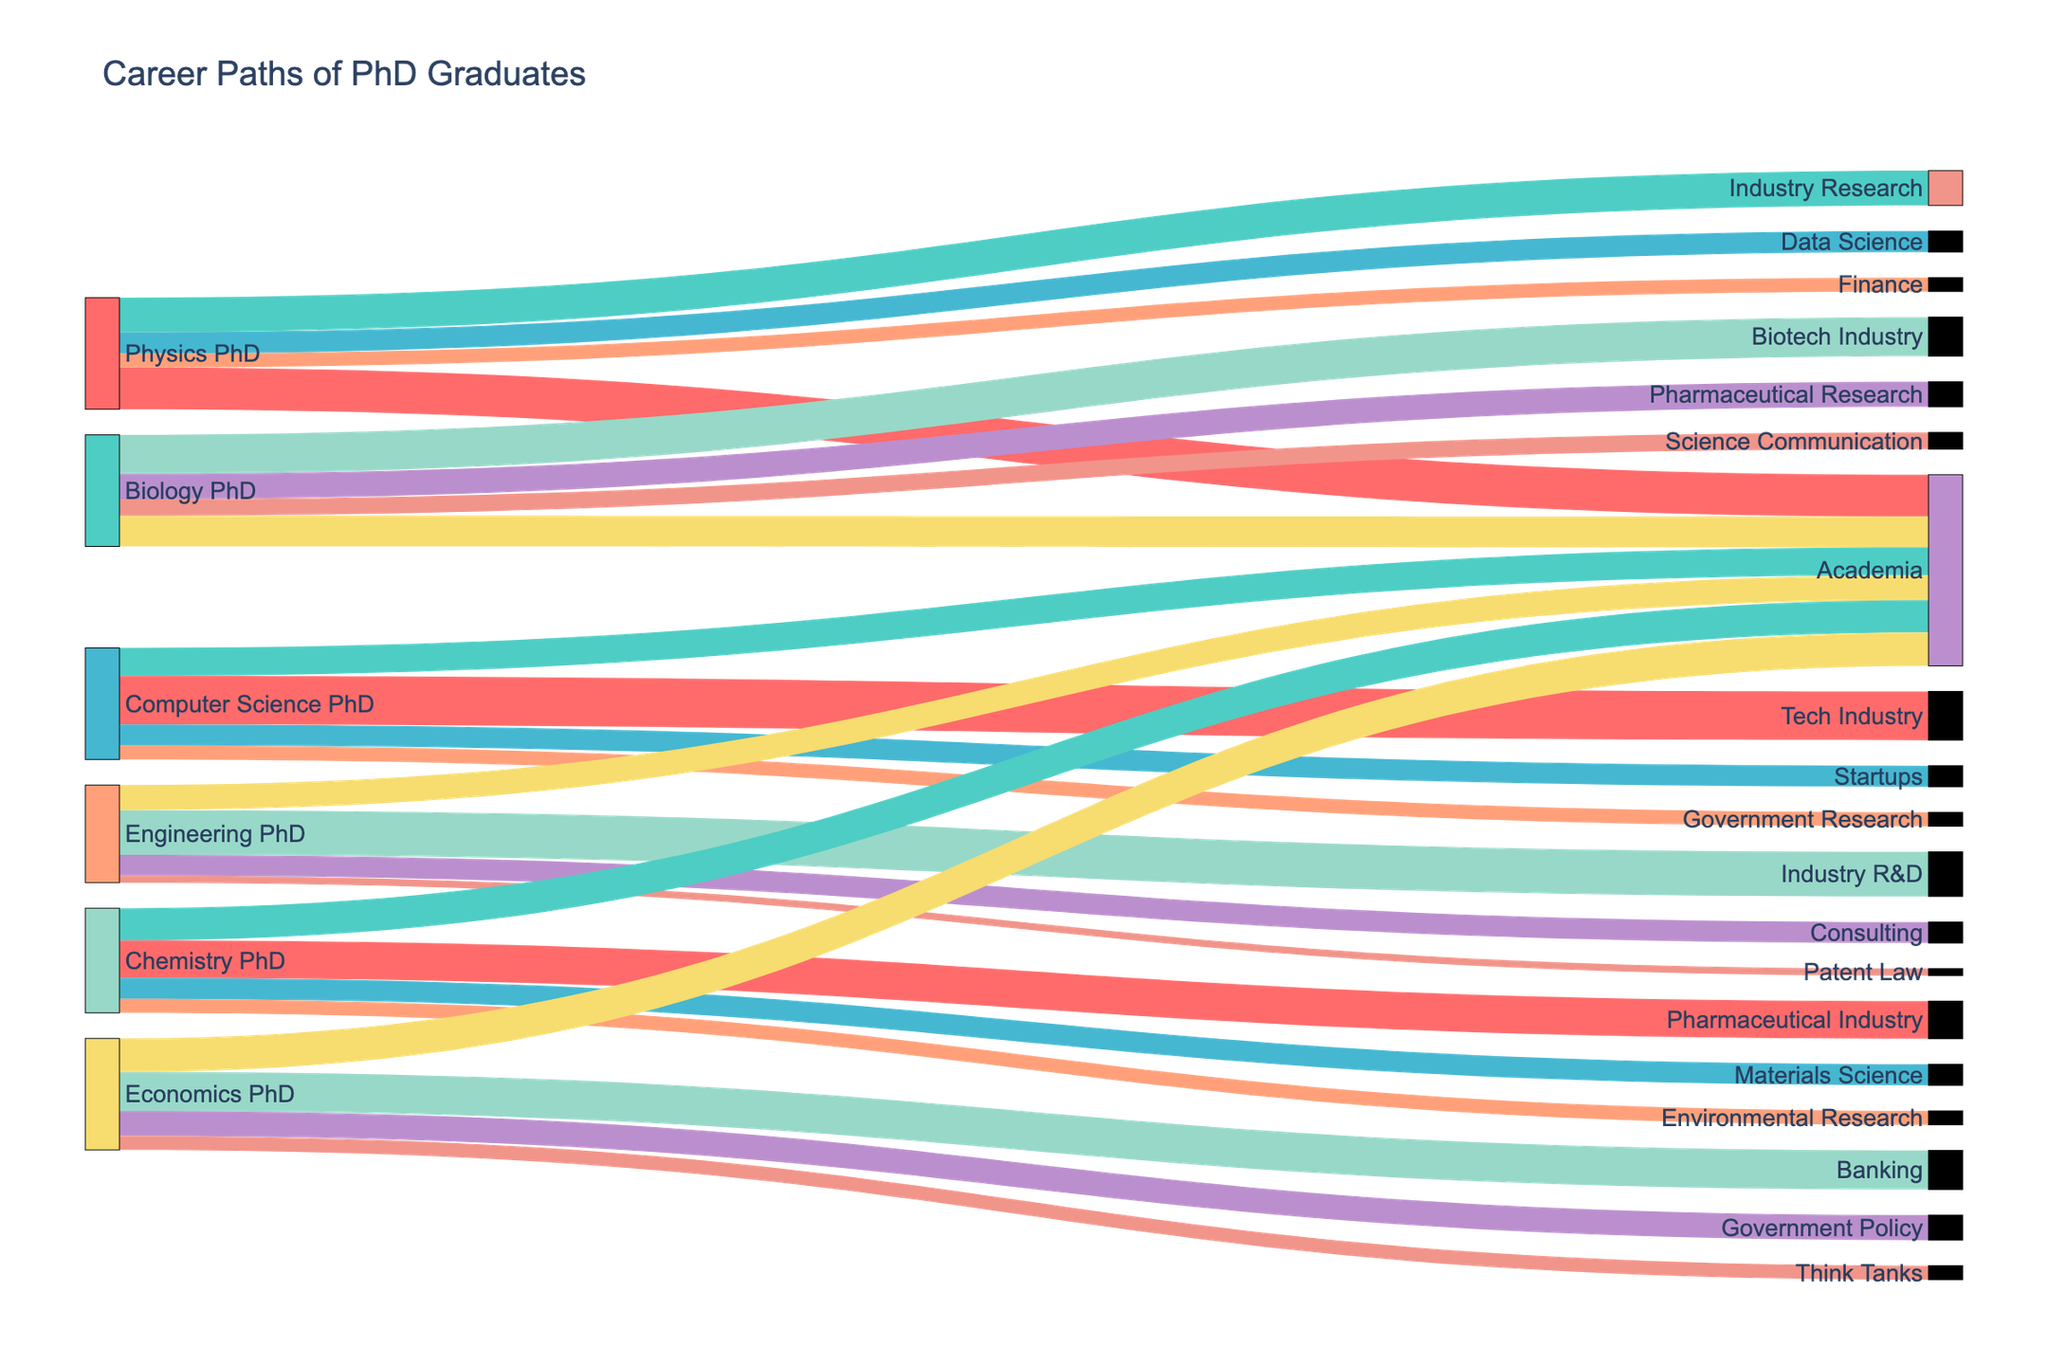What's the title of the figure? The title of the figure is typically located at the top of the visualization and provides a summary of what the figure is about. In this case, the title text is "Career Paths of PhD Graduates".
Answer: Career Paths of PhD Graduates How many different career paths are shown for Physics PhDs? Count the number of unique target labels connected to "Physics PhD" in the figure. The target labels connected here are Academia, Industry Research, Data Science, and Finance.
Answer: 4 Which career path has the highest number of Computer Science PhDs? Identify the highest value of the links connected to "Computer Science PhD". The highest value link goes to the Tech Industry with a value of 350.
Answer: Tech Industry What is the combined number of Biology PhDs in the Biotech Industry and Pharmaceutical Research? Sum the values of the links from "Biology PhD" to "Biotech Industry" and "Pharmaceutical Research". These values are 280 and 180 respectively, so 280 + 180 = 460.
Answer: 460 Which field has the least number of PhD graduates going into patent law? Identify the lowest value among the links. "Engineering PhD" has the lowest value of 50 PhDs moving into Patent Law.
Answer: Engineering PhD Compare the number of Physics PhDs in Academia to Chemistry PhDs in the same field. Which has more? Look at the values of the links connected to "Academia" from both "Physics PhD" and "Chemistry PhD". Physics PhDs in Academia have a value of 300 while Chemistry PhDs in Academia have 230. 300 is more than 230.
Answer: Physics PhDs What is the difference in the number of Engineering PhDs between Consulting and Academia? Subtract the value of "Engineering PhD" in Academia from the value in Consulting. These values are 150 (Consulting) and 180 (Academia), so 150 - 180 = -30. The absolute difference is 30.
Answer: 30 How many career paths are available for Economics PhDs as shown in the figure? Count the unique target labels connected to "Economics PhD". These are Banking, Academia, Government Policy, and Think Tanks, which total to 4.
Answer: 4 What is the total number of PhDs in Data Science from all mentioned disciplines? Identify the values linked to "Data Science" and sum them up. Only "Physics PhD" has a link to Data Science with a value of 150. Hence, 150.
Answer: 150 How is the color of the links determined in this figure? Observe the pattern in the figure. Each link is assigned a color from a given palette in a repeating order (Cycling through '#FF6B6B', '#4ECDC4', etc.). Each unique link color identifies the separate flow paths.
Answer: Repeating color palette 